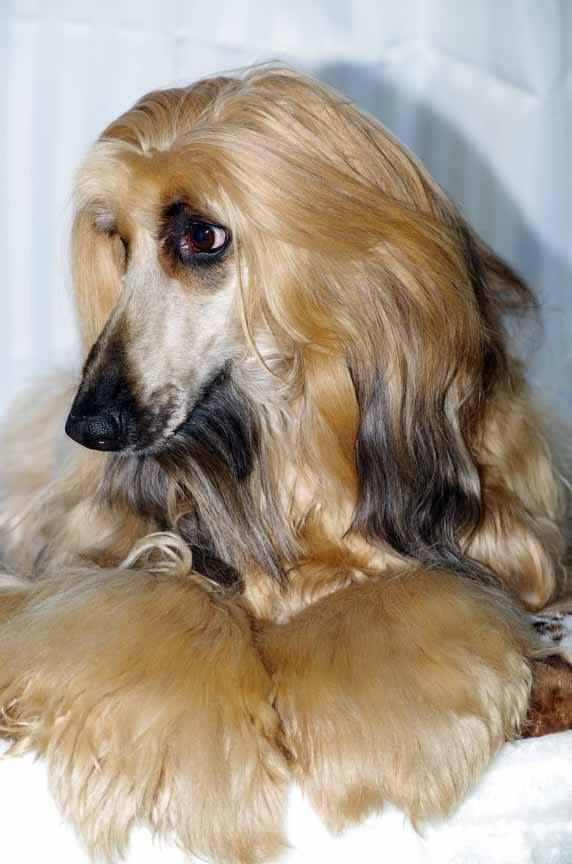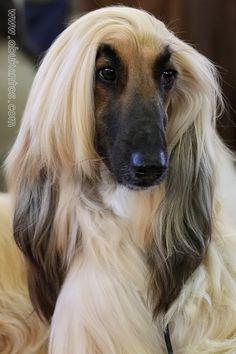The first image is the image on the left, the second image is the image on the right. Considering the images on both sides, is "An image shows a reclining hound with its front paws extended in front of its body." valid? Answer yes or no. Yes. 